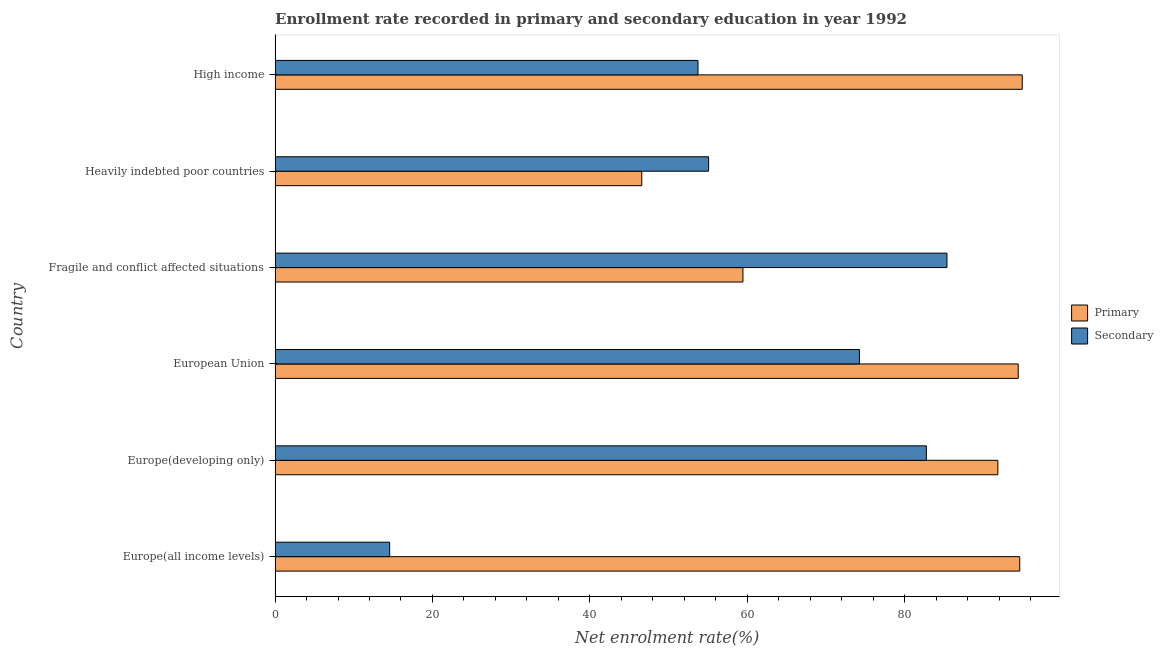How many groups of bars are there?
Provide a short and direct response. 6. Are the number of bars per tick equal to the number of legend labels?
Give a very brief answer. Yes. Are the number of bars on each tick of the Y-axis equal?
Keep it short and to the point. Yes. How many bars are there on the 2nd tick from the top?
Provide a short and direct response. 2. What is the label of the 4th group of bars from the top?
Ensure brevity in your answer.  European Union. In how many cases, is the number of bars for a given country not equal to the number of legend labels?
Your response must be concise. 0. What is the enrollment rate in primary education in Europe(all income levels)?
Make the answer very short. 94.63. Across all countries, what is the maximum enrollment rate in primary education?
Ensure brevity in your answer.  94.95. Across all countries, what is the minimum enrollment rate in primary education?
Offer a terse response. 46.6. In which country was the enrollment rate in secondary education minimum?
Your answer should be very brief. Europe(all income levels). What is the total enrollment rate in primary education in the graph?
Offer a very short reply. 481.93. What is the difference between the enrollment rate in primary education in European Union and that in Fragile and conflict affected situations?
Provide a short and direct response. 34.98. What is the difference between the enrollment rate in primary education in High income and the enrollment rate in secondary education in Fragile and conflict affected situations?
Provide a short and direct response. 9.56. What is the average enrollment rate in secondary education per country?
Make the answer very short. 60.97. What is the difference between the enrollment rate in secondary education and enrollment rate in primary education in Europe(all income levels)?
Your answer should be very brief. -80.07. What is the ratio of the enrollment rate in secondary education in Fragile and conflict affected situations to that in Heavily indebted poor countries?
Give a very brief answer. 1.55. Is the enrollment rate in secondary education in Fragile and conflict affected situations less than that in High income?
Make the answer very short. No. What is the difference between the highest and the second highest enrollment rate in secondary education?
Offer a terse response. 2.62. What is the difference between the highest and the lowest enrollment rate in secondary education?
Your answer should be very brief. 70.82. What does the 1st bar from the top in High income represents?
Make the answer very short. Secondary. What does the 1st bar from the bottom in European Union represents?
Your answer should be compact. Primary. How many bars are there?
Offer a terse response. 12. Are the values on the major ticks of X-axis written in scientific E-notation?
Your response must be concise. No. Does the graph contain grids?
Provide a succinct answer. No. Where does the legend appear in the graph?
Provide a succinct answer. Center right. What is the title of the graph?
Your response must be concise. Enrollment rate recorded in primary and secondary education in year 1992. What is the label or title of the X-axis?
Offer a very short reply. Net enrolment rate(%). What is the Net enrolment rate(%) in Primary in Europe(all income levels)?
Provide a succinct answer. 94.63. What is the Net enrolment rate(%) in Secondary in Europe(all income levels)?
Provide a short and direct response. 14.56. What is the Net enrolment rate(%) of Primary in Europe(developing only)?
Provide a short and direct response. 91.85. What is the Net enrolment rate(%) in Secondary in Europe(developing only)?
Provide a short and direct response. 82.76. What is the Net enrolment rate(%) of Primary in European Union?
Your answer should be very brief. 94.44. What is the Net enrolment rate(%) of Secondary in European Union?
Your response must be concise. 74.26. What is the Net enrolment rate(%) of Primary in Fragile and conflict affected situations?
Give a very brief answer. 59.46. What is the Net enrolment rate(%) in Secondary in Fragile and conflict affected situations?
Give a very brief answer. 85.38. What is the Net enrolment rate(%) in Primary in Heavily indebted poor countries?
Provide a short and direct response. 46.6. What is the Net enrolment rate(%) of Secondary in Heavily indebted poor countries?
Ensure brevity in your answer.  55.09. What is the Net enrolment rate(%) in Primary in High income?
Keep it short and to the point. 94.95. What is the Net enrolment rate(%) in Secondary in High income?
Ensure brevity in your answer.  53.75. Across all countries, what is the maximum Net enrolment rate(%) in Primary?
Keep it short and to the point. 94.95. Across all countries, what is the maximum Net enrolment rate(%) of Secondary?
Offer a very short reply. 85.38. Across all countries, what is the minimum Net enrolment rate(%) in Primary?
Ensure brevity in your answer.  46.6. Across all countries, what is the minimum Net enrolment rate(%) in Secondary?
Offer a terse response. 14.56. What is the total Net enrolment rate(%) in Primary in the graph?
Make the answer very short. 481.93. What is the total Net enrolment rate(%) of Secondary in the graph?
Keep it short and to the point. 365.81. What is the difference between the Net enrolment rate(%) in Primary in Europe(all income levels) and that in Europe(developing only)?
Your answer should be very brief. 2.78. What is the difference between the Net enrolment rate(%) of Secondary in Europe(all income levels) and that in Europe(developing only)?
Give a very brief answer. -68.2. What is the difference between the Net enrolment rate(%) in Primary in Europe(all income levels) and that in European Union?
Your response must be concise. 0.19. What is the difference between the Net enrolment rate(%) of Secondary in Europe(all income levels) and that in European Union?
Offer a terse response. -59.7. What is the difference between the Net enrolment rate(%) in Primary in Europe(all income levels) and that in Fragile and conflict affected situations?
Give a very brief answer. 35.17. What is the difference between the Net enrolment rate(%) of Secondary in Europe(all income levels) and that in Fragile and conflict affected situations?
Provide a succinct answer. -70.82. What is the difference between the Net enrolment rate(%) of Primary in Europe(all income levels) and that in Heavily indebted poor countries?
Offer a very short reply. 48.03. What is the difference between the Net enrolment rate(%) in Secondary in Europe(all income levels) and that in Heavily indebted poor countries?
Your answer should be very brief. -40.53. What is the difference between the Net enrolment rate(%) in Primary in Europe(all income levels) and that in High income?
Your answer should be compact. -0.32. What is the difference between the Net enrolment rate(%) in Secondary in Europe(all income levels) and that in High income?
Give a very brief answer. -39.18. What is the difference between the Net enrolment rate(%) of Primary in Europe(developing only) and that in European Union?
Provide a succinct answer. -2.58. What is the difference between the Net enrolment rate(%) in Secondary in Europe(developing only) and that in European Union?
Your answer should be very brief. 8.5. What is the difference between the Net enrolment rate(%) in Primary in Europe(developing only) and that in Fragile and conflict affected situations?
Provide a short and direct response. 32.4. What is the difference between the Net enrolment rate(%) of Secondary in Europe(developing only) and that in Fragile and conflict affected situations?
Your answer should be compact. -2.62. What is the difference between the Net enrolment rate(%) in Primary in Europe(developing only) and that in Heavily indebted poor countries?
Make the answer very short. 45.26. What is the difference between the Net enrolment rate(%) in Secondary in Europe(developing only) and that in Heavily indebted poor countries?
Provide a succinct answer. 27.67. What is the difference between the Net enrolment rate(%) of Primary in Europe(developing only) and that in High income?
Your answer should be compact. -3.09. What is the difference between the Net enrolment rate(%) in Secondary in Europe(developing only) and that in High income?
Offer a very short reply. 29.02. What is the difference between the Net enrolment rate(%) of Primary in European Union and that in Fragile and conflict affected situations?
Provide a succinct answer. 34.98. What is the difference between the Net enrolment rate(%) in Secondary in European Union and that in Fragile and conflict affected situations?
Offer a terse response. -11.12. What is the difference between the Net enrolment rate(%) in Primary in European Union and that in Heavily indebted poor countries?
Your answer should be compact. 47.84. What is the difference between the Net enrolment rate(%) of Secondary in European Union and that in Heavily indebted poor countries?
Provide a succinct answer. 19.17. What is the difference between the Net enrolment rate(%) in Primary in European Union and that in High income?
Give a very brief answer. -0.51. What is the difference between the Net enrolment rate(%) in Secondary in European Union and that in High income?
Provide a short and direct response. 20.52. What is the difference between the Net enrolment rate(%) in Primary in Fragile and conflict affected situations and that in Heavily indebted poor countries?
Provide a succinct answer. 12.86. What is the difference between the Net enrolment rate(%) of Secondary in Fragile and conflict affected situations and that in Heavily indebted poor countries?
Provide a short and direct response. 30.29. What is the difference between the Net enrolment rate(%) of Primary in Fragile and conflict affected situations and that in High income?
Offer a very short reply. -35.49. What is the difference between the Net enrolment rate(%) in Secondary in Fragile and conflict affected situations and that in High income?
Ensure brevity in your answer.  31.64. What is the difference between the Net enrolment rate(%) in Primary in Heavily indebted poor countries and that in High income?
Your answer should be very brief. -48.35. What is the difference between the Net enrolment rate(%) of Secondary in Heavily indebted poor countries and that in High income?
Offer a terse response. 1.35. What is the difference between the Net enrolment rate(%) of Primary in Europe(all income levels) and the Net enrolment rate(%) of Secondary in Europe(developing only)?
Your answer should be very brief. 11.87. What is the difference between the Net enrolment rate(%) of Primary in Europe(all income levels) and the Net enrolment rate(%) of Secondary in European Union?
Your answer should be compact. 20.37. What is the difference between the Net enrolment rate(%) in Primary in Europe(all income levels) and the Net enrolment rate(%) in Secondary in Fragile and conflict affected situations?
Keep it short and to the point. 9.25. What is the difference between the Net enrolment rate(%) of Primary in Europe(all income levels) and the Net enrolment rate(%) of Secondary in Heavily indebted poor countries?
Keep it short and to the point. 39.54. What is the difference between the Net enrolment rate(%) of Primary in Europe(all income levels) and the Net enrolment rate(%) of Secondary in High income?
Your answer should be very brief. 40.88. What is the difference between the Net enrolment rate(%) of Primary in Europe(developing only) and the Net enrolment rate(%) of Secondary in European Union?
Your response must be concise. 17.59. What is the difference between the Net enrolment rate(%) in Primary in Europe(developing only) and the Net enrolment rate(%) in Secondary in Fragile and conflict affected situations?
Your answer should be very brief. 6.47. What is the difference between the Net enrolment rate(%) of Primary in Europe(developing only) and the Net enrolment rate(%) of Secondary in Heavily indebted poor countries?
Your response must be concise. 36.76. What is the difference between the Net enrolment rate(%) of Primary in Europe(developing only) and the Net enrolment rate(%) of Secondary in High income?
Your answer should be compact. 38.11. What is the difference between the Net enrolment rate(%) of Primary in European Union and the Net enrolment rate(%) of Secondary in Fragile and conflict affected situations?
Offer a terse response. 9.05. What is the difference between the Net enrolment rate(%) of Primary in European Union and the Net enrolment rate(%) of Secondary in Heavily indebted poor countries?
Offer a very short reply. 39.35. What is the difference between the Net enrolment rate(%) of Primary in European Union and the Net enrolment rate(%) of Secondary in High income?
Your answer should be compact. 40.69. What is the difference between the Net enrolment rate(%) of Primary in Fragile and conflict affected situations and the Net enrolment rate(%) of Secondary in Heavily indebted poor countries?
Your response must be concise. 4.36. What is the difference between the Net enrolment rate(%) of Primary in Fragile and conflict affected situations and the Net enrolment rate(%) of Secondary in High income?
Make the answer very short. 5.71. What is the difference between the Net enrolment rate(%) of Primary in Heavily indebted poor countries and the Net enrolment rate(%) of Secondary in High income?
Keep it short and to the point. -7.15. What is the average Net enrolment rate(%) of Primary per country?
Provide a short and direct response. 80.32. What is the average Net enrolment rate(%) of Secondary per country?
Offer a terse response. 60.97. What is the difference between the Net enrolment rate(%) in Primary and Net enrolment rate(%) in Secondary in Europe(all income levels)?
Keep it short and to the point. 80.07. What is the difference between the Net enrolment rate(%) of Primary and Net enrolment rate(%) of Secondary in Europe(developing only)?
Make the answer very short. 9.09. What is the difference between the Net enrolment rate(%) of Primary and Net enrolment rate(%) of Secondary in European Union?
Make the answer very short. 20.18. What is the difference between the Net enrolment rate(%) of Primary and Net enrolment rate(%) of Secondary in Fragile and conflict affected situations?
Keep it short and to the point. -25.93. What is the difference between the Net enrolment rate(%) in Primary and Net enrolment rate(%) in Secondary in Heavily indebted poor countries?
Your answer should be compact. -8.49. What is the difference between the Net enrolment rate(%) of Primary and Net enrolment rate(%) of Secondary in High income?
Offer a terse response. 41.2. What is the ratio of the Net enrolment rate(%) in Primary in Europe(all income levels) to that in Europe(developing only)?
Your answer should be compact. 1.03. What is the ratio of the Net enrolment rate(%) in Secondary in Europe(all income levels) to that in Europe(developing only)?
Offer a very short reply. 0.18. What is the ratio of the Net enrolment rate(%) in Secondary in Europe(all income levels) to that in European Union?
Your answer should be very brief. 0.2. What is the ratio of the Net enrolment rate(%) in Primary in Europe(all income levels) to that in Fragile and conflict affected situations?
Offer a very short reply. 1.59. What is the ratio of the Net enrolment rate(%) of Secondary in Europe(all income levels) to that in Fragile and conflict affected situations?
Provide a short and direct response. 0.17. What is the ratio of the Net enrolment rate(%) in Primary in Europe(all income levels) to that in Heavily indebted poor countries?
Keep it short and to the point. 2.03. What is the ratio of the Net enrolment rate(%) of Secondary in Europe(all income levels) to that in Heavily indebted poor countries?
Make the answer very short. 0.26. What is the ratio of the Net enrolment rate(%) of Primary in Europe(all income levels) to that in High income?
Provide a succinct answer. 1. What is the ratio of the Net enrolment rate(%) of Secondary in Europe(all income levels) to that in High income?
Offer a very short reply. 0.27. What is the ratio of the Net enrolment rate(%) in Primary in Europe(developing only) to that in European Union?
Provide a succinct answer. 0.97. What is the ratio of the Net enrolment rate(%) of Secondary in Europe(developing only) to that in European Union?
Provide a succinct answer. 1.11. What is the ratio of the Net enrolment rate(%) of Primary in Europe(developing only) to that in Fragile and conflict affected situations?
Keep it short and to the point. 1.54. What is the ratio of the Net enrolment rate(%) of Secondary in Europe(developing only) to that in Fragile and conflict affected situations?
Give a very brief answer. 0.97. What is the ratio of the Net enrolment rate(%) of Primary in Europe(developing only) to that in Heavily indebted poor countries?
Provide a short and direct response. 1.97. What is the ratio of the Net enrolment rate(%) in Secondary in Europe(developing only) to that in Heavily indebted poor countries?
Offer a very short reply. 1.5. What is the ratio of the Net enrolment rate(%) in Primary in Europe(developing only) to that in High income?
Provide a succinct answer. 0.97. What is the ratio of the Net enrolment rate(%) in Secondary in Europe(developing only) to that in High income?
Ensure brevity in your answer.  1.54. What is the ratio of the Net enrolment rate(%) of Primary in European Union to that in Fragile and conflict affected situations?
Provide a short and direct response. 1.59. What is the ratio of the Net enrolment rate(%) of Secondary in European Union to that in Fragile and conflict affected situations?
Offer a very short reply. 0.87. What is the ratio of the Net enrolment rate(%) in Primary in European Union to that in Heavily indebted poor countries?
Make the answer very short. 2.03. What is the ratio of the Net enrolment rate(%) of Secondary in European Union to that in Heavily indebted poor countries?
Offer a very short reply. 1.35. What is the ratio of the Net enrolment rate(%) in Primary in European Union to that in High income?
Give a very brief answer. 0.99. What is the ratio of the Net enrolment rate(%) in Secondary in European Union to that in High income?
Provide a short and direct response. 1.38. What is the ratio of the Net enrolment rate(%) of Primary in Fragile and conflict affected situations to that in Heavily indebted poor countries?
Give a very brief answer. 1.28. What is the ratio of the Net enrolment rate(%) of Secondary in Fragile and conflict affected situations to that in Heavily indebted poor countries?
Your response must be concise. 1.55. What is the ratio of the Net enrolment rate(%) in Primary in Fragile and conflict affected situations to that in High income?
Your response must be concise. 0.63. What is the ratio of the Net enrolment rate(%) of Secondary in Fragile and conflict affected situations to that in High income?
Your answer should be very brief. 1.59. What is the ratio of the Net enrolment rate(%) of Primary in Heavily indebted poor countries to that in High income?
Ensure brevity in your answer.  0.49. What is the ratio of the Net enrolment rate(%) of Secondary in Heavily indebted poor countries to that in High income?
Ensure brevity in your answer.  1.03. What is the difference between the highest and the second highest Net enrolment rate(%) in Primary?
Ensure brevity in your answer.  0.32. What is the difference between the highest and the second highest Net enrolment rate(%) in Secondary?
Your response must be concise. 2.62. What is the difference between the highest and the lowest Net enrolment rate(%) in Primary?
Provide a short and direct response. 48.35. What is the difference between the highest and the lowest Net enrolment rate(%) of Secondary?
Ensure brevity in your answer.  70.82. 